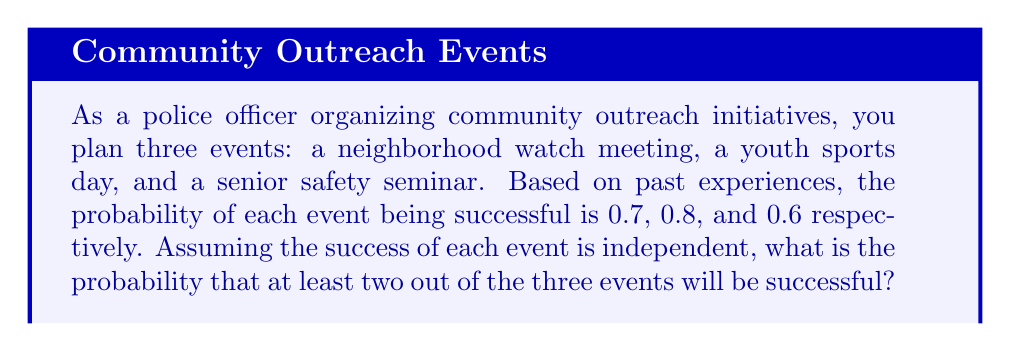Can you solve this math problem? Let's approach this step-by-step:

1) First, let's define our events:
   A: Neighborhood watch meeting is successful (P(A) = 0.7)
   B: Youth sports day is successful (P(B) = 0.8)
   C: Senior safety seminar is successful (P(C) = 0.6)

2) We need to find P(at least 2 successful) = P(2 successful) + P(3 successful)

3) Let's start with P(3 successful):
   P(A and B and C) = P(A) × P(B) × P(C) = 0.7 × 0.8 × 0.6 = 0.336

4) Now, let's calculate P(2 successful):
   This can happen in three ways: AB, AC, or BC

   P(AB not C) = P(A) × P(B) × (1 - P(C)) = 0.7 × 0.8 × 0.4 = 0.224
   P(AC not B) = P(A) × (1 - P(B)) × P(C) = 0.7 × 0.2 × 0.6 = 0.084
   P(BC not A) = (1 - P(A)) × P(B) × P(C) = 0.3 × 0.8 × 0.6 = 0.144

   P(2 successful) = 0.224 + 0.084 + 0.144 = 0.452

5) Therefore, P(at least 2 successful) = P(2 successful) + P(3 successful)
                                       = 0.452 + 0.336 = 0.788
Answer: The probability that at least two out of the three community outreach events will be successful is 0.788 or 78.8%. 